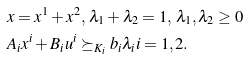Convert formula to latex. <formula><loc_0><loc_0><loc_500><loc_500>& x = x ^ { 1 } + x ^ { 2 } , \, \lambda _ { 1 } + \lambda _ { 2 } = 1 , \, \lambda _ { 1 } , \lambda _ { 2 } \geq 0 \\ & A _ { i } x ^ { i } + B _ { i } u ^ { i } \succeq _ { K _ { i } } b _ { i } \lambda _ { i } i = 1 , 2 .</formula> 